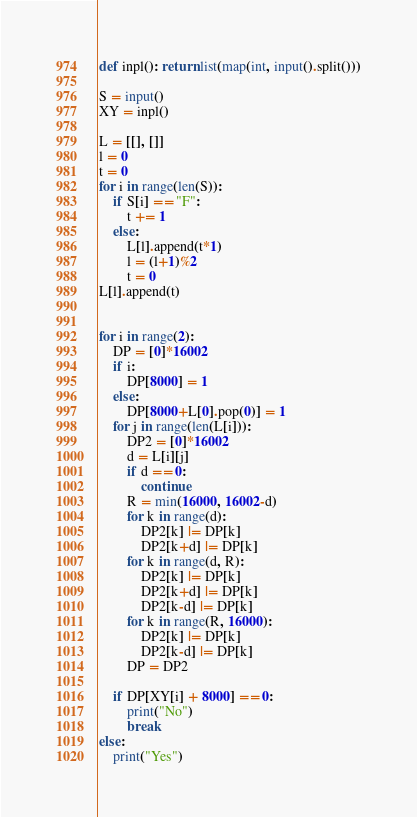<code> <loc_0><loc_0><loc_500><loc_500><_Python_>def inpl(): return list(map(int, input().split()))

S = input()
XY = inpl()

L = [[], []]
l = 0
t = 0
for i in range(len(S)):
    if S[i] == "F":
        t += 1
    else:
        L[l].append(t*1)
        l = (l+1)%2
        t = 0
L[l].append(t)


for i in range(2):
    DP = [0]*16002
    if i:
        DP[8000] = 1
    else:
        DP[8000+L[0].pop(0)] = 1
    for j in range(len(L[i])):
        DP2 = [0]*16002
        d = L[i][j]
        if d == 0:
            continue
        R = min(16000, 16002-d)
        for k in range(d):
            DP2[k] |= DP[k]
            DP2[k+d] |= DP[k]
        for k in range(d, R):
            DP2[k] |= DP[k]
            DP2[k+d] |= DP[k]
            DP2[k-d] |= DP[k]
        for k in range(R, 16000):
            DP2[k] |= DP[k]
            DP2[k-d] |= DP[k]
        DP = DP2

    if DP[XY[i] + 8000] == 0:
        print("No")
        break
else:
    print("Yes")
</code> 